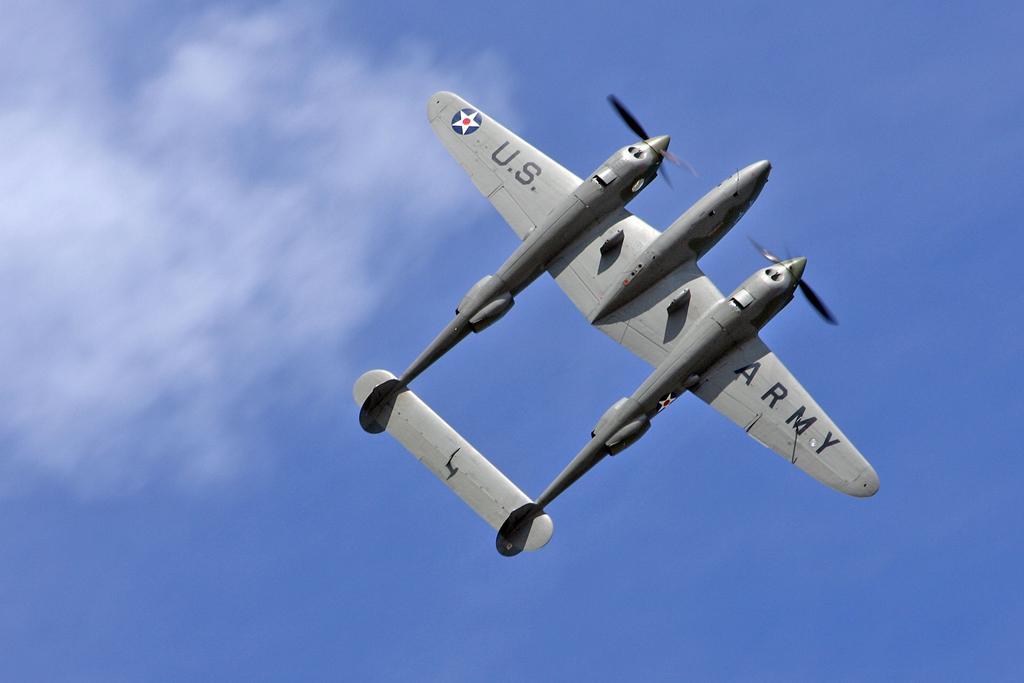In one or two sentences, can you explain what this image depicts? On the left side, there is an aircraft in gray color flying in the air. In the background, there are are clouds in the blue sky. 